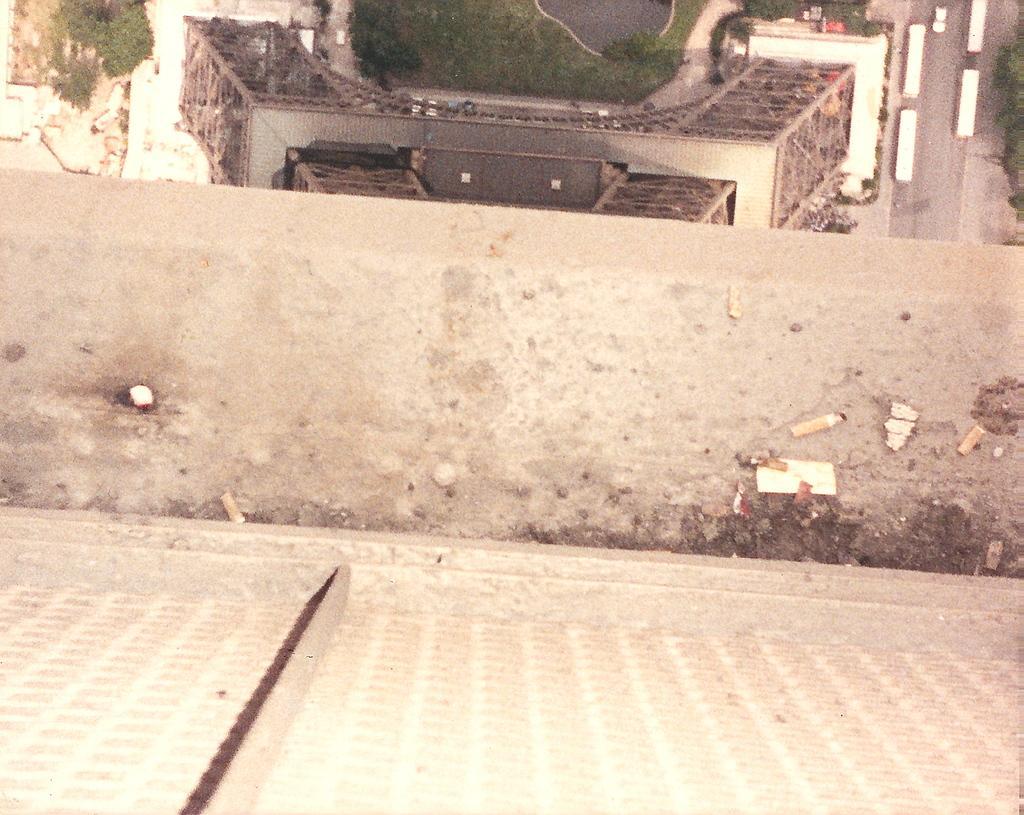Could you give a brief overview of what you see in this image? The image is taken from top of the tower, there is a pavement and on that there is a lot of dust, below the pavement there is a tower and around the tower there are some vehicles and trees. 